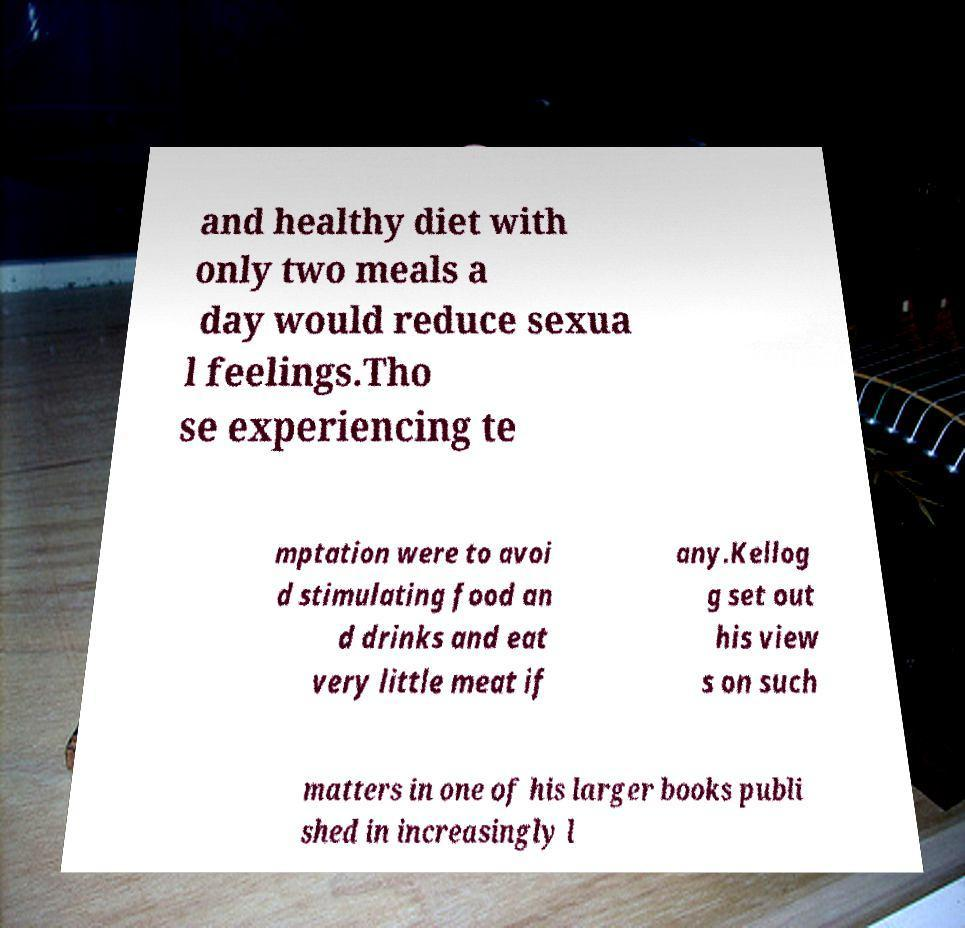Could you assist in decoding the text presented in this image and type it out clearly? and healthy diet with only two meals a day would reduce sexua l feelings.Tho se experiencing te mptation were to avoi d stimulating food an d drinks and eat very little meat if any.Kellog g set out his view s on such matters in one of his larger books publi shed in increasingly l 